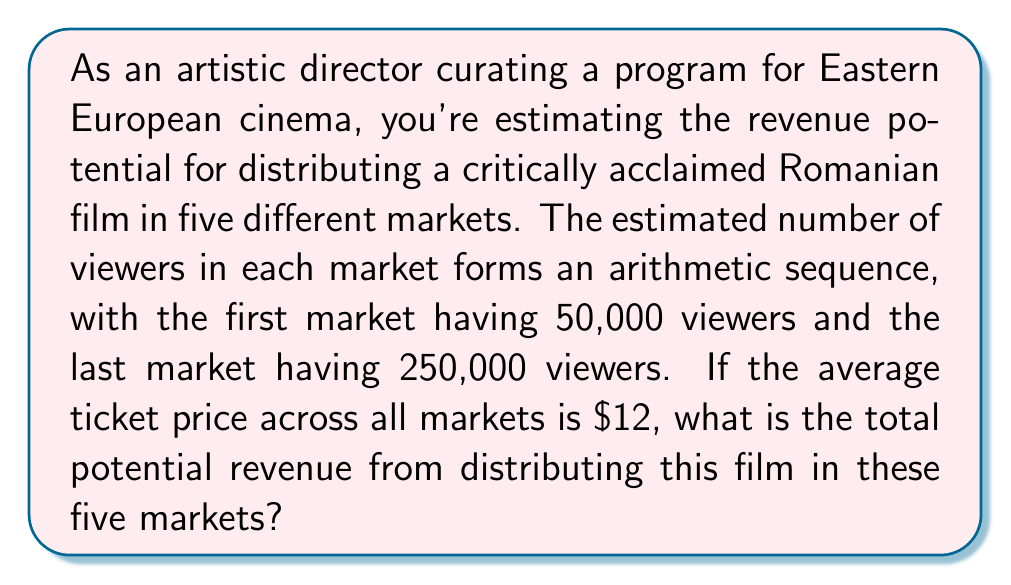Provide a solution to this math problem. Let's approach this step-by-step:

1) First, we need to find the arithmetic sequence of viewers. We know:
   - There are 5 markets
   - The first term $a_1 = 50,000$
   - The last term $a_5 = 250,000$

2) In an arithmetic sequence, the difference $d$ between each term is constant. We can find this using the formula:

   $$d = \frac{a_n - a_1}{n - 1} = \frac{250,000 - 50,000}{5 - 1} = \frac{200,000}{4} = 50,000$$

3) Now we know the sequence is: 50,000, 100,000, 150,000, 200,000, 250,000

4) To find the total number of viewers, we need to sum this sequence. We can use the formula for the sum of an arithmetic sequence:

   $$S_n = \frac{n}{2}(a_1 + a_n)$$

   Where $n$ is the number of terms, $a_1$ is the first term, and $a_n$ is the last term.

5) Plugging in our values:

   $$S_5 = \frac{5}{2}(50,000 + 250,000) = \frac{5}{2}(300,000) = 750,000$$

6) So the total number of viewers across all markets is 750,000.

7) Given that the average ticket price is $12, we can calculate the total revenue:

   $$\text{Total Revenue} = 750,000 \times $12 = $9,000,000$$

Therefore, the total potential revenue from distributing this film in these five markets is $9,000,000.
Answer: $9,000,000 